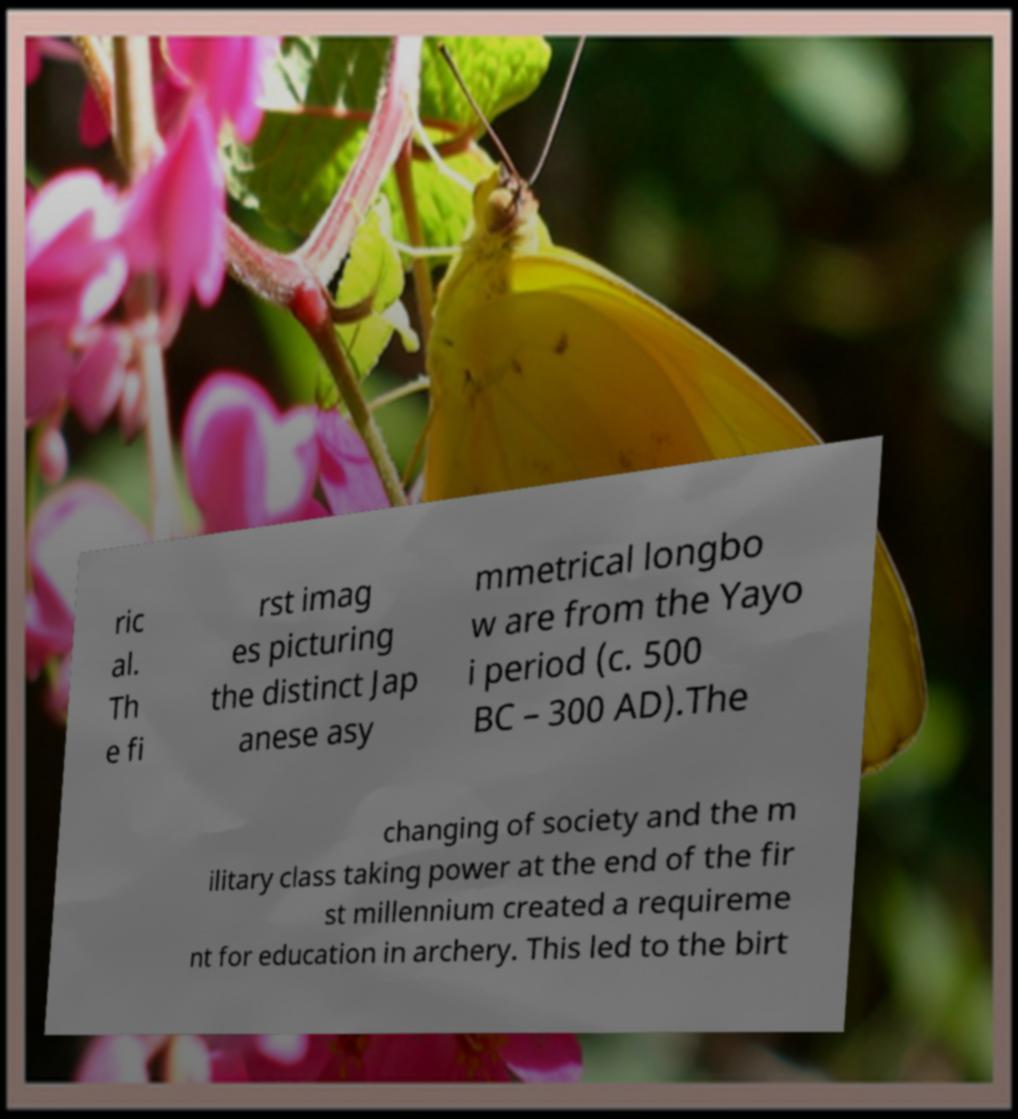For documentation purposes, I need the text within this image transcribed. Could you provide that? ric al. Th e fi rst imag es picturing the distinct Jap anese asy mmetrical longbo w are from the Yayo i period (c. 500 BC – 300 AD).The changing of society and the m ilitary class taking power at the end of the fir st millennium created a requireme nt for education in archery. This led to the birt 